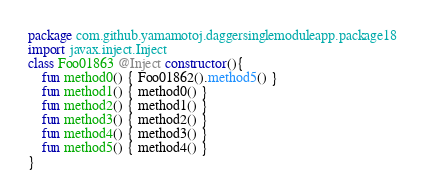<code> <loc_0><loc_0><loc_500><loc_500><_Kotlin_>package com.github.yamamotoj.daggersinglemoduleapp.package18
import javax.inject.Inject
class Foo01863 @Inject constructor(){
    fun method0() { Foo01862().method5() }
    fun method1() { method0() }
    fun method2() { method1() }
    fun method3() { method2() }
    fun method4() { method3() }
    fun method5() { method4() }
}
</code> 